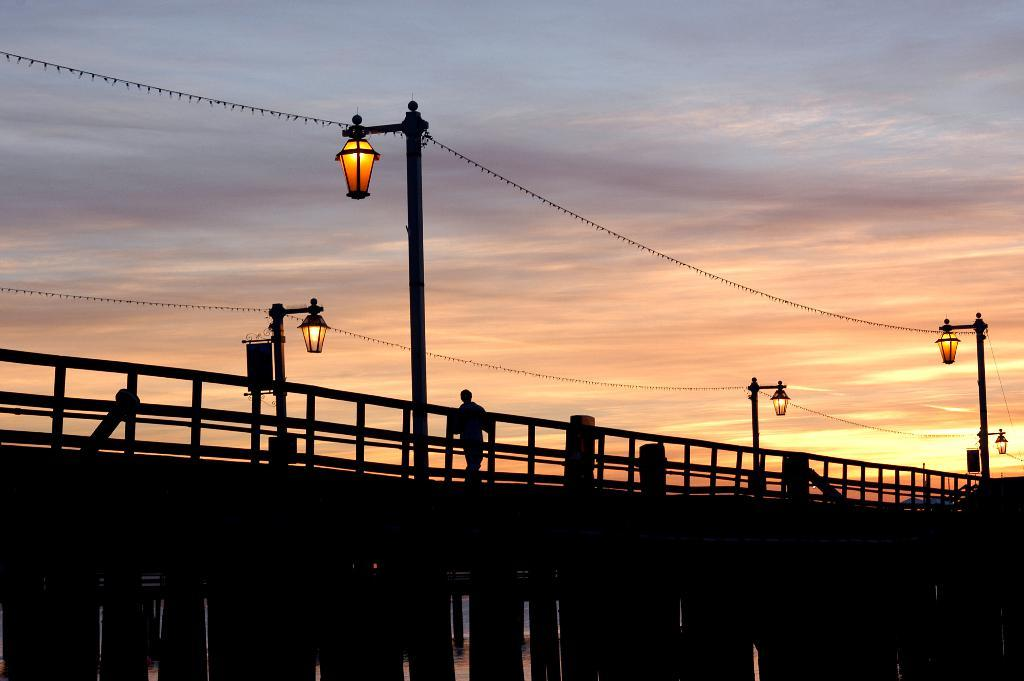What is the person in the image doing? There is a person walking on the bridge in the image. What can be seen attached to the bridge? Wires for street lights are visible in the image. What is visible in the background of the image? The sky is visible in the background of the image. How would you describe the weather based on the sky? The sky appears to be cloudy in the image. What type of quiver is the person carrying on the bridge? There is no quiver present in the image; the person is simply walking on the bridge. 